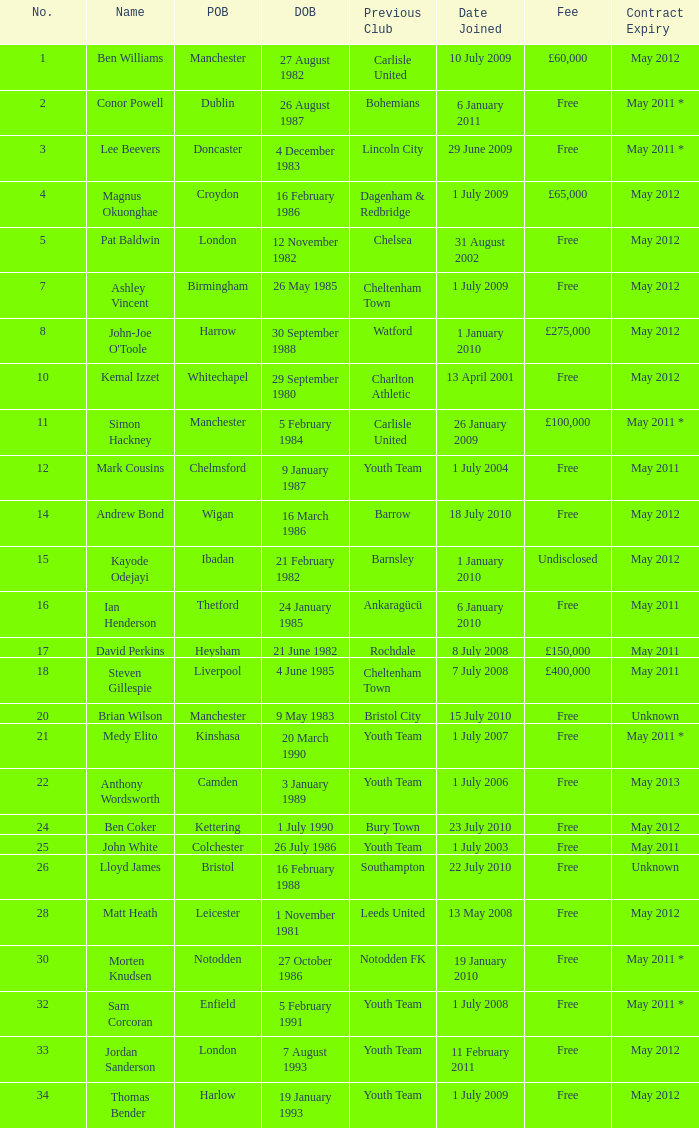Write the full table. {'header': ['No.', 'Name', 'POB', 'DOB', 'Previous Club', 'Date Joined', 'Fee', 'Contract Expiry'], 'rows': [['1', 'Ben Williams', 'Manchester', '27 August 1982', 'Carlisle United', '10 July 2009', '£60,000', 'May 2012'], ['2', 'Conor Powell', 'Dublin', '26 August 1987', 'Bohemians', '6 January 2011', 'Free', 'May 2011 *'], ['3', 'Lee Beevers', 'Doncaster', '4 December 1983', 'Lincoln City', '29 June 2009', 'Free', 'May 2011 *'], ['4', 'Magnus Okuonghae', 'Croydon', '16 February 1986', 'Dagenham & Redbridge', '1 July 2009', '£65,000', 'May 2012'], ['5', 'Pat Baldwin', 'London', '12 November 1982', 'Chelsea', '31 August 2002', 'Free', 'May 2012'], ['7', 'Ashley Vincent', 'Birmingham', '26 May 1985', 'Cheltenham Town', '1 July 2009', 'Free', 'May 2012'], ['8', "John-Joe O'Toole", 'Harrow', '30 September 1988', 'Watford', '1 January 2010', '£275,000', 'May 2012'], ['10', 'Kemal Izzet', 'Whitechapel', '29 September 1980', 'Charlton Athletic', '13 April 2001', 'Free', 'May 2012'], ['11', 'Simon Hackney', 'Manchester', '5 February 1984', 'Carlisle United', '26 January 2009', '£100,000', 'May 2011 *'], ['12', 'Mark Cousins', 'Chelmsford', '9 January 1987', 'Youth Team', '1 July 2004', 'Free', 'May 2011'], ['14', 'Andrew Bond', 'Wigan', '16 March 1986', 'Barrow', '18 July 2010', 'Free', 'May 2012'], ['15', 'Kayode Odejayi', 'Ibadan', '21 February 1982', 'Barnsley', '1 January 2010', 'Undisclosed', 'May 2012'], ['16', 'Ian Henderson', 'Thetford', '24 January 1985', 'Ankaragücü', '6 January 2010', 'Free', 'May 2011'], ['17', 'David Perkins', 'Heysham', '21 June 1982', 'Rochdale', '8 July 2008', '£150,000', 'May 2011'], ['18', 'Steven Gillespie', 'Liverpool', '4 June 1985', 'Cheltenham Town', '7 July 2008', '£400,000', 'May 2011'], ['20', 'Brian Wilson', 'Manchester', '9 May 1983', 'Bristol City', '15 July 2010', 'Free', 'Unknown'], ['21', 'Medy Elito', 'Kinshasa', '20 March 1990', 'Youth Team', '1 July 2007', 'Free', 'May 2011 *'], ['22', 'Anthony Wordsworth', 'Camden', '3 January 1989', 'Youth Team', '1 July 2006', 'Free', 'May 2013'], ['24', 'Ben Coker', 'Kettering', '1 July 1990', 'Bury Town', '23 July 2010', 'Free', 'May 2012'], ['25', 'John White', 'Colchester', '26 July 1986', 'Youth Team', '1 July 2003', 'Free', 'May 2011'], ['26', 'Lloyd James', 'Bristol', '16 February 1988', 'Southampton', '22 July 2010', 'Free', 'Unknown'], ['28', 'Matt Heath', 'Leicester', '1 November 1981', 'Leeds United', '13 May 2008', 'Free', 'May 2012'], ['30', 'Morten Knudsen', 'Notodden', '27 October 1986', 'Notodden FK', '19 January 2010', 'Free', 'May 2011 *'], ['32', 'Sam Corcoran', 'Enfield', '5 February 1991', 'Youth Team', '1 July 2008', 'Free', 'May 2011 *'], ['33', 'Jordan Sanderson', 'London', '7 August 1993', 'Youth Team', '11 February 2011', 'Free', 'May 2012'], ['34', 'Thomas Bender', 'Harlow', '19 January 1993', 'Youth Team', '1 July 2009', 'Free', 'May 2012']]} For the no. 7 what is the date of birth 26 May 1985. 